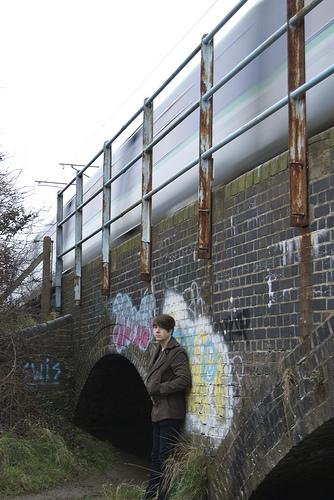State any additional information regarding the man's actions or position. The man is standing under the bridge and leaning on the wall with his hands in his pockets. What is the main subject in the image and their action? The main subject is a man leaning on the wall with his hands in his pockets. Give a brief summary of the environment surrounding the bridge. There is a tunnel under the bridge, dirt path, green grass, trees without leaves, and dried plants. Enumerate any visible signs of wear or aging in the image. Rusty railing and guardrails, dead tree, dried plants, and an old bridge are signs of wear or aging. Describe any notable colors mentioned for different objects in the image. Light blue words in graffiti, green grass, brown tree, black bricked wall, and rusty metal. State the features of the bridge in the image. The bridge is made of cinderblocks, has rusty guardrails, and train tracks on top. Provide a short description of the man's appearance and clothing. The young man has long hair, a comb over, wears a long-sleeve brown coat, and black pants. Enumerate what kind of plants and their conditions can be found in the image. Weeds on the ground, grass growing on the side of the bridge, and dried plants are present. List the different elements related to the appearance of the bridge. Cinderblock structure, rusty guardrails and railing, graffiti, and train tracks on top. Mention any unusual artwork present in the image. There is graffiti on the wall, including a blue smiley face. Notice the interesting painting on the woman's face. Image information indicates there is a lady standing beside a bridge, but there is no mention of a painting on her face. This misleading instruction adds a nonexistent detail to an existing object. Describe the man leaning on the wall in the image. A young man wearing a long sleeve brown coat and long dark pants with hands in his pocket leans on the wall. Is there any vegetation present in the image? Yes, there are weeds, dried plants, and a dead tree. Look for a small dog playing near the bridge. There is no mention of a dog in the image information, but this instruction implies that there is a dog present in the scene. How many captions mention the color of the jacket worn by the person in the image? Two captions mention the color of the jacket, one says it is grey and another says it is brown. Based on the captions, what is unusual about the coat the man is wearing? The coat is described as both grey and brown, which is unusual and may be an inconsistency. How many captions mention the rusty railing on the bridge? Three captions mention the rusty railing. Find the birds flying in the clear sky above the bridge. While the image information does mention that the sky is clear, there is no mention of birds. Adding a subject that is not present in the image is misleading. Find the caption that refers to a tunnel. "Tunnel going under the bridge," with coordinates X:68, Y:349, Width:101, Height:101. Is there any text visible in the image? Yes, the graffiti on the wall contains light blue text and a blue smiley face. Based on the information given, is the bridge over a river, a road, or train tracks? The bridge is over train tracks. Analyze the interaction between the man leaning on the wall and his surroundings. The man is detached from his surroundings, leaning on the wall with graffiti, under the bridge with rusty railings. What emotions does the image evoke? The image evokes a sense of urban decay and loneliness. What type of wall is the man leaning on? The man is leaning on a black-bricked wall with graffiti. Tell me if the flag on top of the bridge is waving. There is no mention of a flag in the image information. Asking the viewer to find a flag creates confusion and misleads them. What color are the cinderblocks that make up the bridge? The cinderblocks are black in color. What is the status of the trees in the image? The trees are dead or dried, with one tree without any leaves. Identify three different attributes mentioned about the man leaning on the wall. He wears a brown coat, has long hair, and has hands in his pocket. There's an umbrella hanging from one of the trees without leaves. The image information talks about a tree without leaves, but does not mention any umbrella. Introducing a new object not present in the image information misleads the viewer. Identify the object with coordinates X:104, Y:289, Width:145, Height:145. The object is graffiti on the wall of the bridge. Detect any anomalies in the image. There are no significant anomalies; the scene is typical of a neglected urban environment. Which caption refers to the young man with long hair? "Young man with long hair," with coordinates X:135, Y:304, Width:49, Height:49. What is the color of the graffiti on the wall? The graffiti is light blue and includes a blue smiley face. Can you see the pink flowers blooming on the wall? There are no pink flowers mentioned in the image information, and the adjective "pink" leads the viewer to search for an object that doesn't exist in the image. 